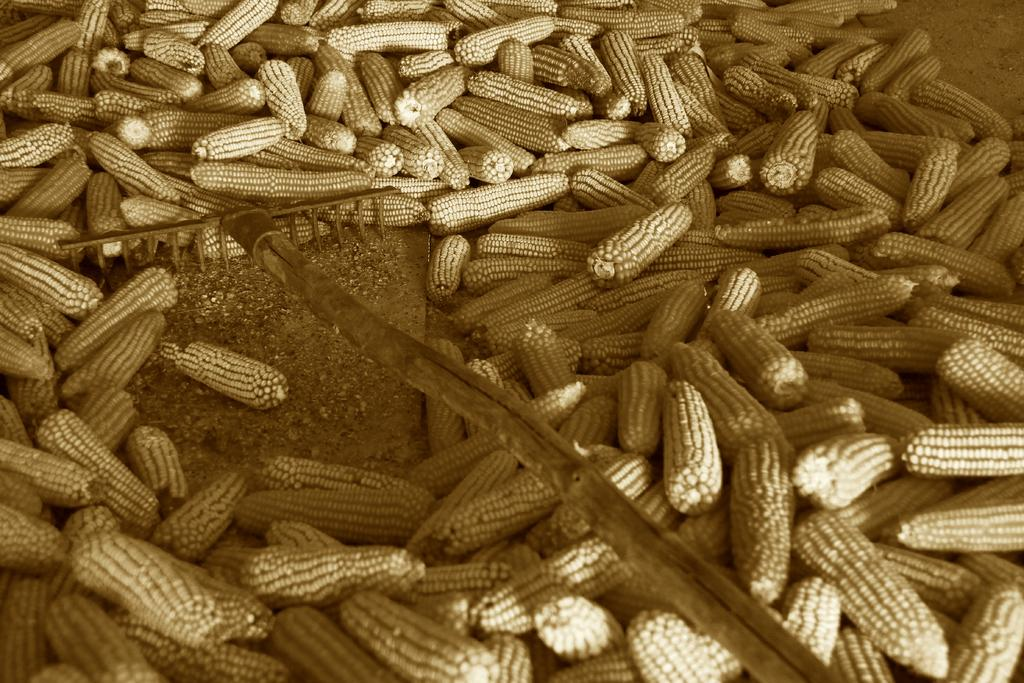What type of food is present in the image? There is corn in the image. What object is also visible in the image? There is a stick in the image. How is the corn arranged in the image? There is a heap of corn in the image. What color scheme is used in the image? The image is black and white. What type of plate is used to serve the corn in the image? There is no plate present in the image; it only shows corn and a stick. 